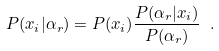Convert formula to latex. <formula><loc_0><loc_0><loc_500><loc_500>P ( x _ { i } | \alpha _ { r } ) = P ( x _ { i } ) \frac { P ( \alpha _ { r } | x _ { i } ) } { P ( \alpha _ { r } ) } \ .</formula> 